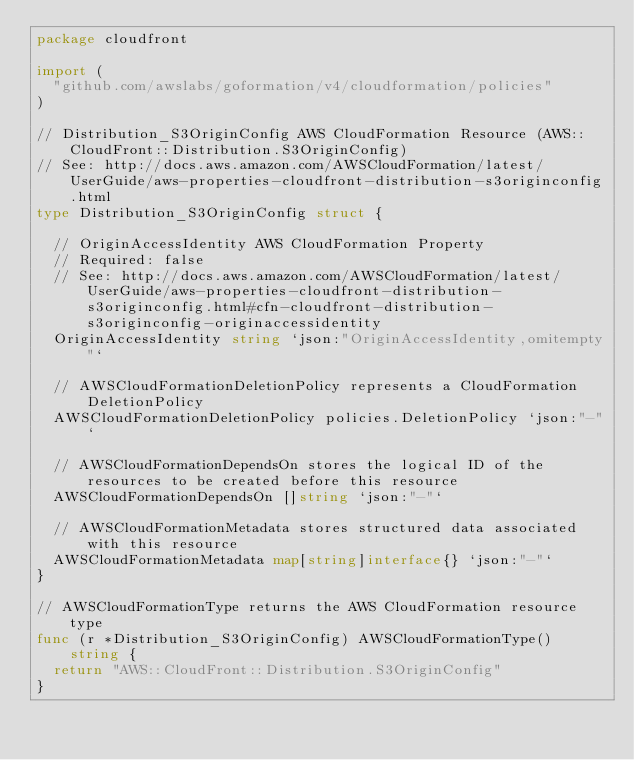Convert code to text. <code><loc_0><loc_0><loc_500><loc_500><_Go_>package cloudfront

import (
	"github.com/awslabs/goformation/v4/cloudformation/policies"
)

// Distribution_S3OriginConfig AWS CloudFormation Resource (AWS::CloudFront::Distribution.S3OriginConfig)
// See: http://docs.aws.amazon.com/AWSCloudFormation/latest/UserGuide/aws-properties-cloudfront-distribution-s3originconfig.html
type Distribution_S3OriginConfig struct {

	// OriginAccessIdentity AWS CloudFormation Property
	// Required: false
	// See: http://docs.aws.amazon.com/AWSCloudFormation/latest/UserGuide/aws-properties-cloudfront-distribution-s3originconfig.html#cfn-cloudfront-distribution-s3originconfig-originaccessidentity
	OriginAccessIdentity string `json:"OriginAccessIdentity,omitempty"`

	// AWSCloudFormationDeletionPolicy represents a CloudFormation DeletionPolicy
	AWSCloudFormationDeletionPolicy policies.DeletionPolicy `json:"-"`

	// AWSCloudFormationDependsOn stores the logical ID of the resources to be created before this resource
	AWSCloudFormationDependsOn []string `json:"-"`

	// AWSCloudFormationMetadata stores structured data associated with this resource
	AWSCloudFormationMetadata map[string]interface{} `json:"-"`
}

// AWSCloudFormationType returns the AWS CloudFormation resource type
func (r *Distribution_S3OriginConfig) AWSCloudFormationType() string {
	return "AWS::CloudFront::Distribution.S3OriginConfig"
}
</code> 